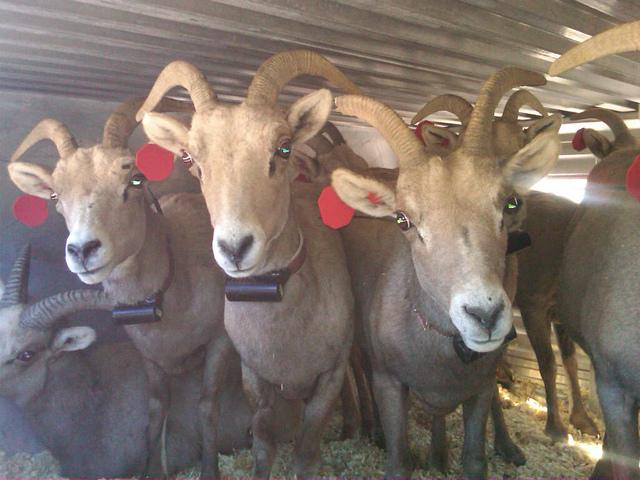What type of loose material is strewn on the floor where the animals are standing?

Choices:
A) sawdust
B) grain
C) leaves
D) straw sawdust 